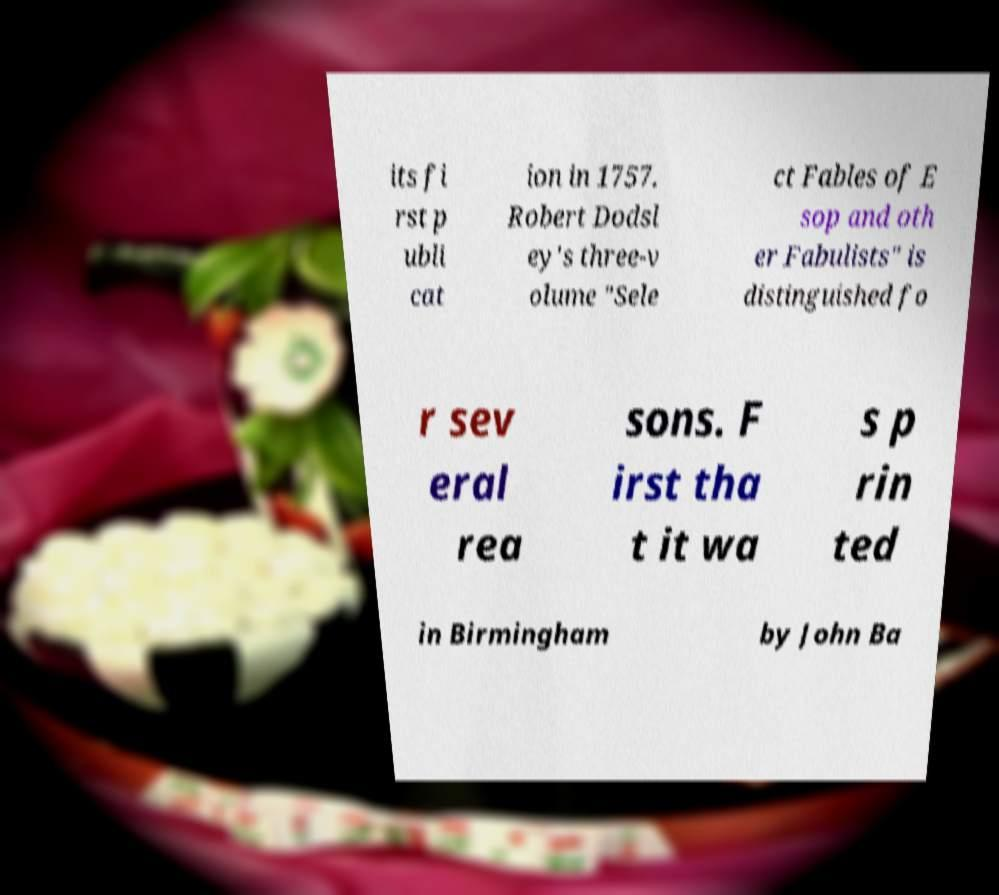Please read and relay the text visible in this image. What does it say? its fi rst p ubli cat ion in 1757. Robert Dodsl ey's three-v olume "Sele ct Fables of E sop and oth er Fabulists" is distinguished fo r sev eral rea sons. F irst tha t it wa s p rin ted in Birmingham by John Ba 